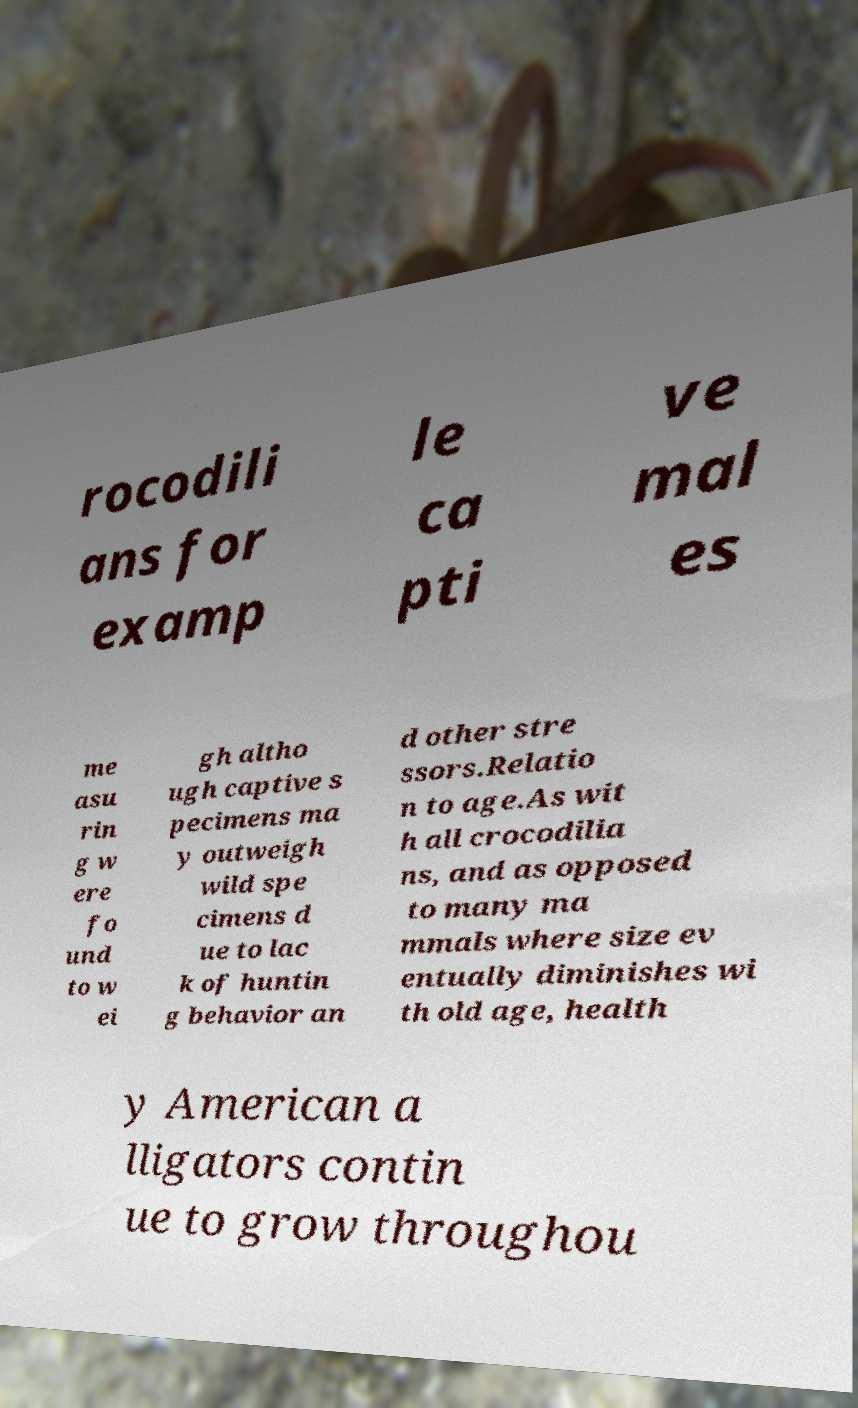Can you accurately transcribe the text from the provided image for me? rocodili ans for examp le ca pti ve mal es me asu rin g w ere fo und to w ei gh altho ugh captive s pecimens ma y outweigh wild spe cimens d ue to lac k of huntin g behavior an d other stre ssors.Relatio n to age.As wit h all crocodilia ns, and as opposed to many ma mmals where size ev entually diminishes wi th old age, health y American a lligators contin ue to grow throughou 